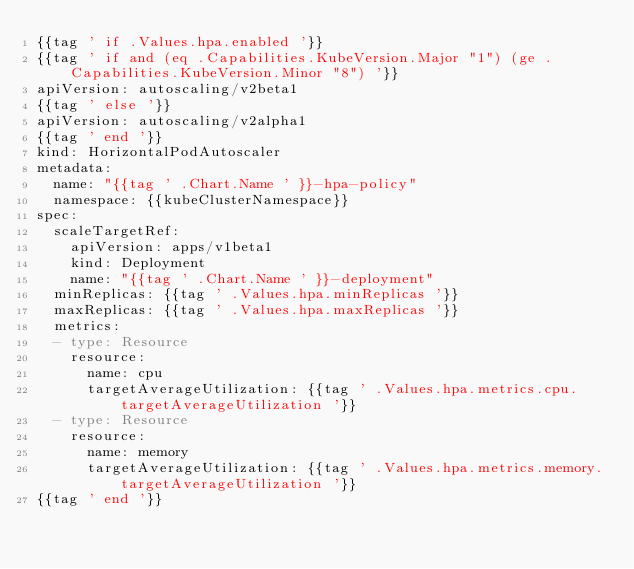Convert code to text. <code><loc_0><loc_0><loc_500><loc_500><_YAML_>{{tag ' if .Values.hpa.enabled '}}
{{tag ' if and (eq .Capabilities.KubeVersion.Major "1") (ge .Capabilities.KubeVersion.Minor "8") '}}
apiVersion: autoscaling/v2beta1
{{tag ' else '}}
apiVersion: autoscaling/v2alpha1
{{tag ' end '}}
kind: HorizontalPodAutoscaler
metadata:
  name: "{{tag ' .Chart.Name ' }}-hpa-policy"
  namespace: {{kubeClusterNamespace}}
spec:
  scaleTargetRef:
    apiVersion: apps/v1beta1
    kind: Deployment
    name: "{{tag ' .Chart.Name ' }}-deployment"
  minReplicas: {{tag ' .Values.hpa.minReplicas '}}
  maxReplicas: {{tag ' .Values.hpa.maxReplicas '}}
  metrics:
  - type: Resource
    resource:
      name: cpu
      targetAverageUtilization: {{tag ' .Values.hpa.metrics.cpu.targetAverageUtilization '}}
  - type: Resource
    resource:
      name: memory
      targetAverageUtilization: {{tag ' .Values.hpa.metrics.memory.targetAverageUtilization '}}
{{tag ' end '}}</code> 